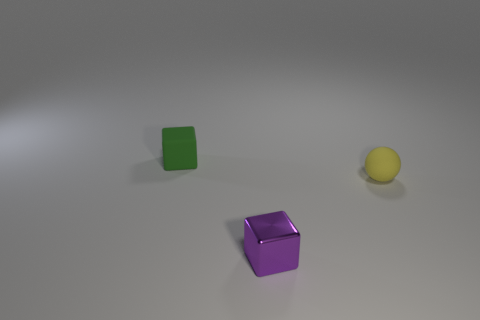Add 3 green rubber things. How many objects exist? 6 Subtract all spheres. How many objects are left? 2 Subtract all big brown matte blocks. Subtract all tiny yellow rubber objects. How many objects are left? 2 Add 1 purple objects. How many purple objects are left? 2 Add 1 metal cubes. How many metal cubes exist? 2 Subtract 0 red cubes. How many objects are left? 3 